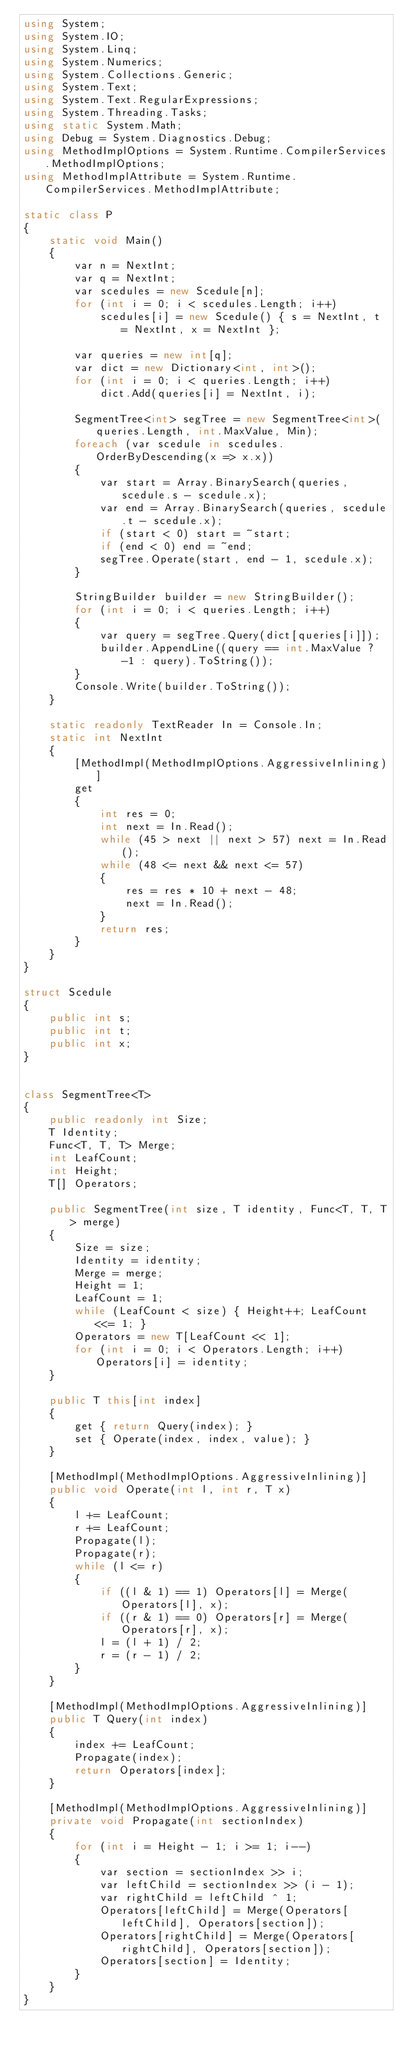Convert code to text. <code><loc_0><loc_0><loc_500><loc_500><_C#_>using System;
using System.IO;
using System.Linq;
using System.Numerics;
using System.Collections.Generic;
using System.Text;
using System.Text.RegularExpressions;
using System.Threading.Tasks;
using static System.Math;
using Debug = System.Diagnostics.Debug;
using MethodImplOptions = System.Runtime.CompilerServices.MethodImplOptions;
using MethodImplAttribute = System.Runtime.CompilerServices.MethodImplAttribute;

static class P
{
    static void Main()
    {
        var n = NextInt;
        var q = NextInt;
        var scedules = new Scedule[n];
        for (int i = 0; i < scedules.Length; i++)
            scedules[i] = new Scedule() { s = NextInt, t = NextInt, x = NextInt };

        var queries = new int[q];
        var dict = new Dictionary<int, int>();
        for (int i = 0; i < queries.Length; i++)
            dict.Add(queries[i] = NextInt, i);

        SegmentTree<int> segTree = new SegmentTree<int>(queries.Length, int.MaxValue, Min);
        foreach (var scedule in scedules.OrderByDescending(x => x.x))
        {
            var start = Array.BinarySearch(queries, scedule.s - scedule.x);
            var end = Array.BinarySearch(queries, scedule.t - scedule.x);
            if (start < 0) start = ~start;
            if (end < 0) end = ~end;
            segTree.Operate(start, end - 1, scedule.x);
        }

        StringBuilder builder = new StringBuilder();
        for (int i = 0; i < queries.Length; i++)
        {
            var query = segTree.Query(dict[queries[i]]);
            builder.AppendLine((query == int.MaxValue ? -1 : query).ToString());
        }
        Console.Write(builder.ToString());
    }

    static readonly TextReader In = Console.In;
    static int NextInt
    {
        [MethodImpl(MethodImplOptions.AggressiveInlining)]
        get
        {
            int res = 0;
            int next = In.Read();
            while (45 > next || next > 57) next = In.Read();
            while (48 <= next && next <= 57)
            {
                res = res * 10 + next - 48;
                next = In.Read();
            }
            return res;
        }
    }
}

struct Scedule
{
    public int s;
    public int t;
    public int x;
}


class SegmentTree<T>
{
    public readonly int Size;
    T Identity;
    Func<T, T, T> Merge;
    int LeafCount;
    int Height;
    T[] Operators;

    public SegmentTree(int size, T identity, Func<T, T, T> merge)
    {
        Size = size;
        Identity = identity;
        Merge = merge;
        Height = 1;
        LeafCount = 1;
        while (LeafCount < size) { Height++; LeafCount <<= 1; }
        Operators = new T[LeafCount << 1];
        for (int i = 0; i < Operators.Length; i++) Operators[i] = identity;
    }

    public T this[int index]
    {
        get { return Query(index); }
        set { Operate(index, index, value); }
    }

    [MethodImpl(MethodImplOptions.AggressiveInlining)]
    public void Operate(int l, int r, T x)
    {
        l += LeafCount;
        r += LeafCount;
        Propagate(l);
        Propagate(r);
        while (l <= r)
        {
            if ((l & 1) == 1) Operators[l] = Merge(Operators[l], x);
            if ((r & 1) == 0) Operators[r] = Merge(Operators[r], x);
            l = (l + 1) / 2;
            r = (r - 1) / 2;
        }
    }

    [MethodImpl(MethodImplOptions.AggressiveInlining)]
    public T Query(int index)
    {
        index += LeafCount;
        Propagate(index);
        return Operators[index];
    }

    [MethodImpl(MethodImplOptions.AggressiveInlining)]
    private void Propagate(int sectionIndex)
    {
        for (int i = Height - 1; i >= 1; i--)
        {
            var section = sectionIndex >> i;
            var leftChild = sectionIndex >> (i - 1);
            var rightChild = leftChild ^ 1;
            Operators[leftChild] = Merge(Operators[leftChild], Operators[section]);
            Operators[rightChild] = Merge(Operators[rightChild], Operators[section]);
            Operators[section] = Identity;
        }
    }
}
</code> 